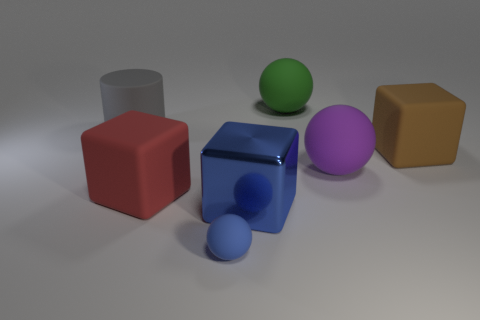Subtract all big balls. How many balls are left? 1 Add 2 large green spheres. How many objects exist? 9 Subtract all red cubes. How many cubes are left? 2 Subtract 3 blocks. How many blocks are left? 0 Subtract all blocks. How many objects are left? 4 Subtract 0 yellow balls. How many objects are left? 7 Subtract all red cylinders. Subtract all red spheres. How many cylinders are left? 1 Subtract all gray spheres. How many red cylinders are left? 0 Subtract all cylinders. Subtract all big blue cubes. How many objects are left? 5 Add 4 big cylinders. How many big cylinders are left? 5 